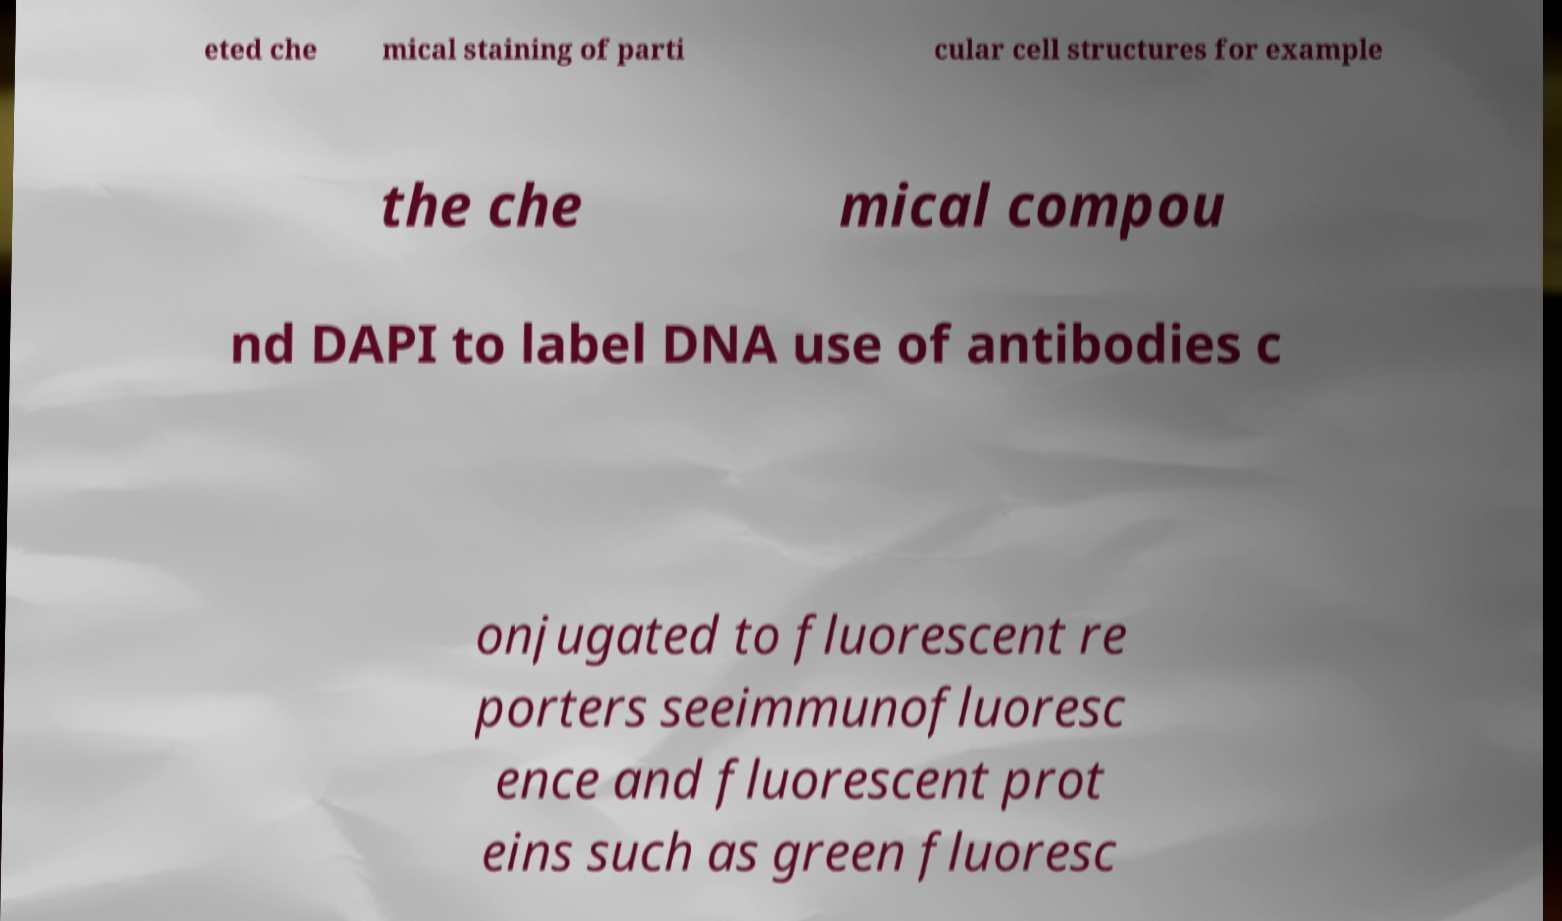What messages or text are displayed in this image? I need them in a readable, typed format. eted che mical staining of parti cular cell structures for example the che mical compou nd DAPI to label DNA use of antibodies c onjugated to fluorescent re porters seeimmunofluoresc ence and fluorescent prot eins such as green fluoresc 